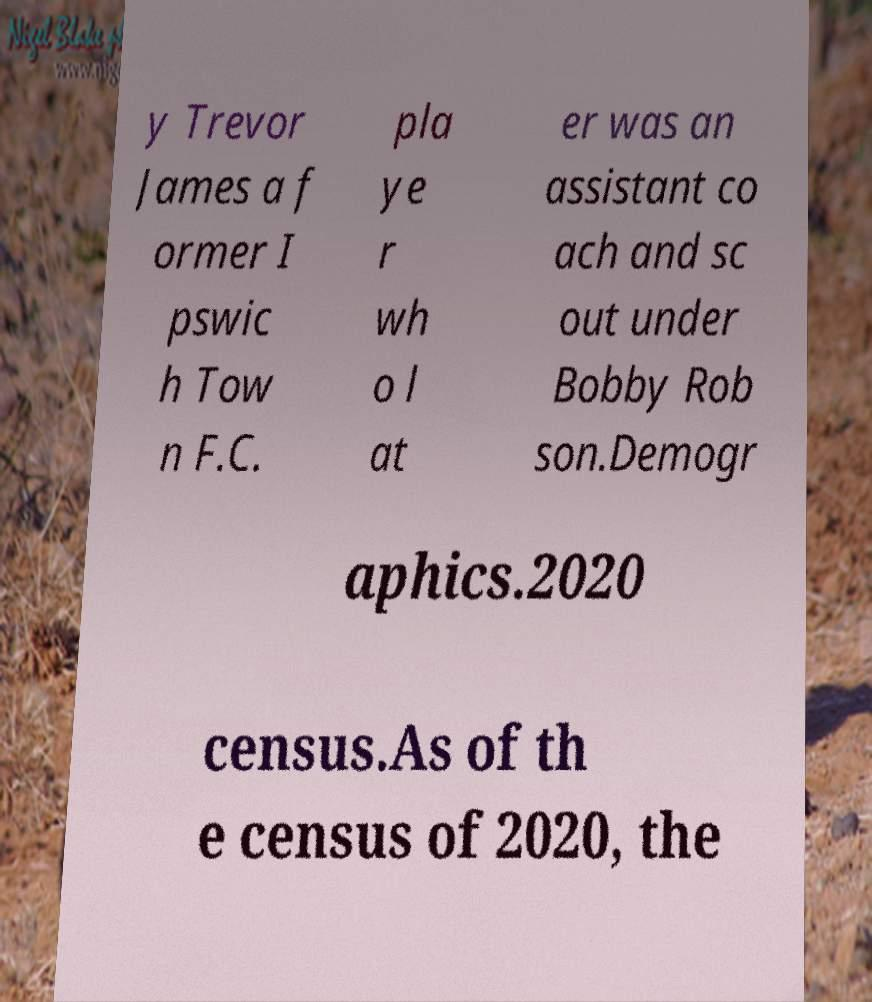Can you accurately transcribe the text from the provided image for me? y Trevor James a f ormer I pswic h Tow n F.C. pla ye r wh o l at er was an assistant co ach and sc out under Bobby Rob son.Demogr aphics.2020 census.As of th e census of 2020, the 